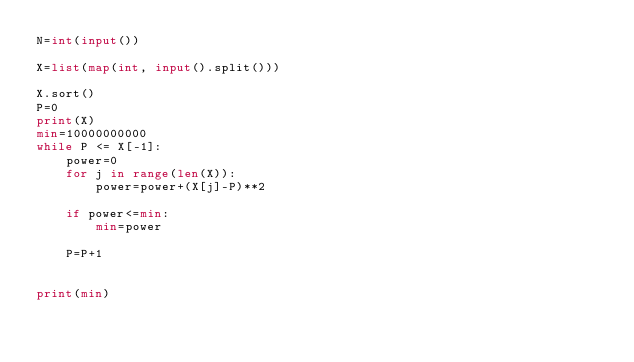<code> <loc_0><loc_0><loc_500><loc_500><_Python_>N=int(input())

X=list(map(int, input().split()))

X.sort()
P=0
print(X)
min=10000000000
while P <= X[-1]:
    power=0
    for j in range(len(X)):
        power=power+(X[j]-P)**2

    if power<=min:
        min=power

    P=P+1


print(min)</code> 